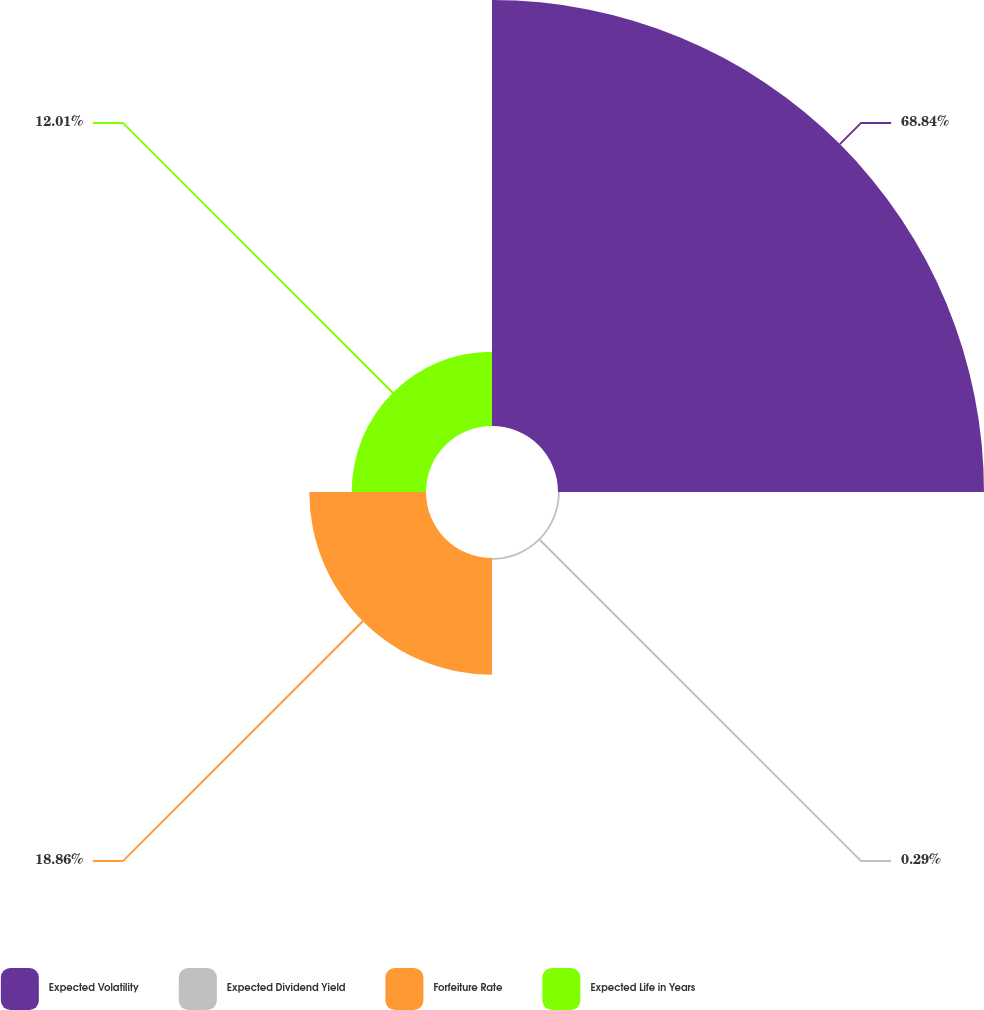Convert chart. <chart><loc_0><loc_0><loc_500><loc_500><pie_chart><fcel>Expected Volatility<fcel>Expected Dividend Yield<fcel>Forfeiture Rate<fcel>Expected Life in Years<nl><fcel>68.83%<fcel>0.29%<fcel>18.86%<fcel>12.01%<nl></chart> 